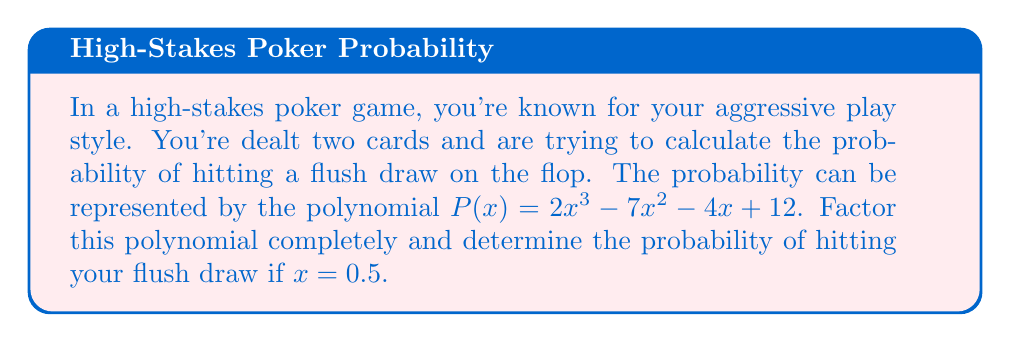Can you solve this math problem? Let's approach this step-by-step:

1) First, we need to factor the polynomial $P(x) = 2x^3 - 7x^2 - 4x + 12$

2) We can start by looking for a common factor. In this case, there is no common factor for all terms.

3) Next, let's try the rational root theorem. The possible rational roots are the factors of the constant term (12): ±1, ±2, ±3, ±4, ±6, ±12

4) Testing these, we find that $x = 2$ is a root. So $(x - 2)$ is a factor.

5) We can use polynomial long division to divide $P(x)$ by $(x - 2)$:

   $2x^3 - 7x^2 - 4x + 12 = (x - 2)(2x^2 - 3x - 6)$

6) Now we need to factor the quadratic $2x^2 - 3x - 6$

7) The quadratic formula gives us:
   
   $x = \frac{3 \pm \sqrt{9 + 48}}{4} = \frac{3 \pm \sqrt{57}}{4}$

8) This can be written as:

   $x = \frac{3 + 3\sqrt{3}}{4}$ or $x = \frac{3 - 3\sqrt{3}}{4}$

9) Therefore, the fully factored polynomial is:

   $P(x) = (x - 2)(2x - \frac{3 + 3\sqrt{3}}{2})(2x - \frac{3 - 3\sqrt{3}}{2})$

10) To find the probability when $x = 0.5$, we substitute this value:

    $P(0.5) = (0.5 - 2)(2(0.5) - \frac{3 + 3\sqrt{3}}{2})(2(0.5) - \frac{3 - 3\sqrt{3}}{2})$
    
    $= (-1.5)(-2.09878...)(-0.40122...) = 1.26316...$

11) Therefore, the probability of hitting your flush draw is approximately 0.2632 or 26.32%
Answer: The fully factored polynomial is:

$$P(x) = (x - 2)(2x - \frac{3 + 3\sqrt{3}}{2})(2x - \frac{3 - 3\sqrt{3}}{2})$$

The probability of hitting your flush draw when $x = 0.5$ is approximately 0.2632 or 26.32%. 